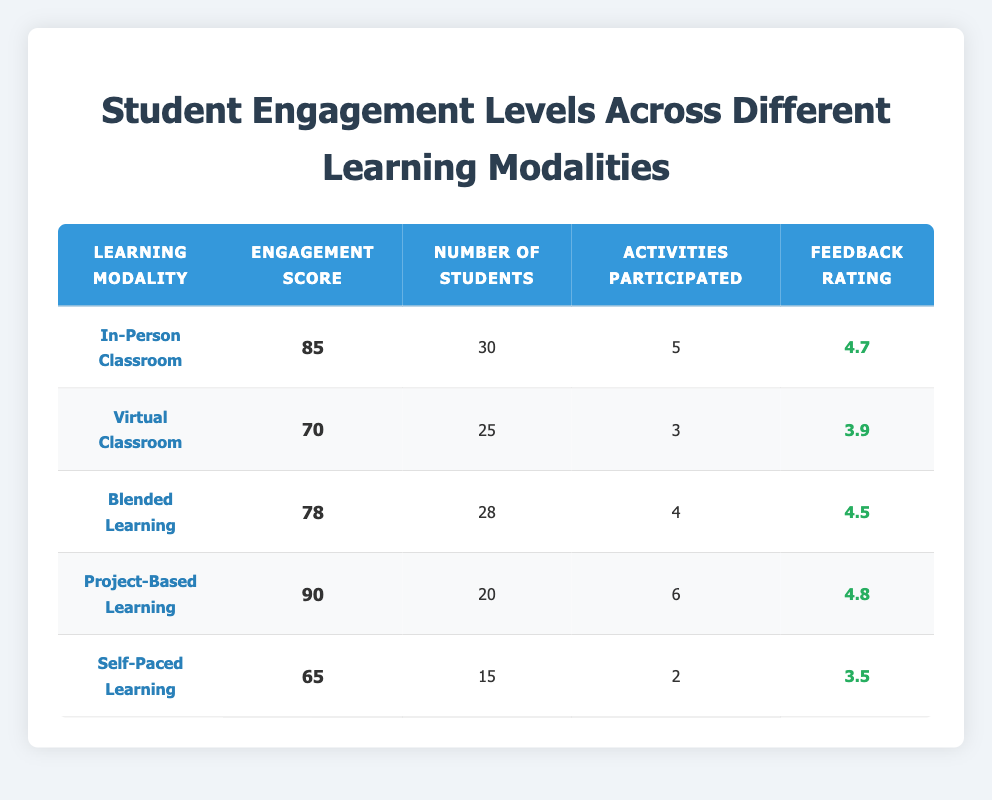What is the engagement score for Project-Based Learning? The table lists the engagement score for each learning modality. The engagement score for Project-Based Learning is explicitly shown as 90.
Answer: 90 How many students participated in the Self-Paced Learning modality? The number of students is clearly listed for each learning modality. For Self-Paced Learning, the number of students is mentioned as 15.
Answer: 15 Which learning modality has the highest feedback rating? The feedback ratings for all modalities are compared. Project-Based Learning has the highest feedback rating of 4.8, which is more than the ratings for the other modalities.
Answer: Project-Based Learning What is the average engagement score across all learning modalities? The engagement scores are 85, 70, 78, 90, and 65. To find the average, sum these scores (85 + 70 + 78 + 90 + 65 = 388) and divide by the number of modalities (5). The average engagement score is 388/5 = 77.6.
Answer: 77.6 Is the number of students in Virtual Classroom higher than in Blended Learning? The table shows that the number of students in Virtual Classroom is 25 and in Blended Learning is 28. Since 25 is less than 28, the answer is no.
Answer: No What is the total number of activities participated by all students in In-Person Classroom and Project-Based Learning combined? Find the activities participated in both modalities: In-Person Classroom has 5 activities and Project-Based Learning has 6 activities. Combine them by adding (5 + 6 = 11) to find the total.
Answer: 11 How does the average feedback rating of Blended Learning compare to that of Self-Paced Learning? The feedback ratings are 4.5 for Blended Learning and 3.5 for Self-Paced Learning. To compare, we note that 4.5 is greater than 3.5, indicating that Blended Learning has a better rating.
Answer: Blended Learning has a better rating Which learning modality has the lowest engagement score and what is that score? The scores are compared to find the lowest value. Self-Paced Learning has the lowest engagement score of 65, which is less than the scores of the other modalities.
Answer: Self-Paced Learning, 65 If all students from all modalities participated in 4 activities, would the average activities participated increase or decrease? Calculate the current average activities: (5 + 3 + 4 + 6 + 2) / 5 = 4. The proposed average with 4 activities for all 118 students (30 + 25 + 28 + 20 + 15) is 4. Since 4 equals the average, it wouldn't change.
Answer: No change 